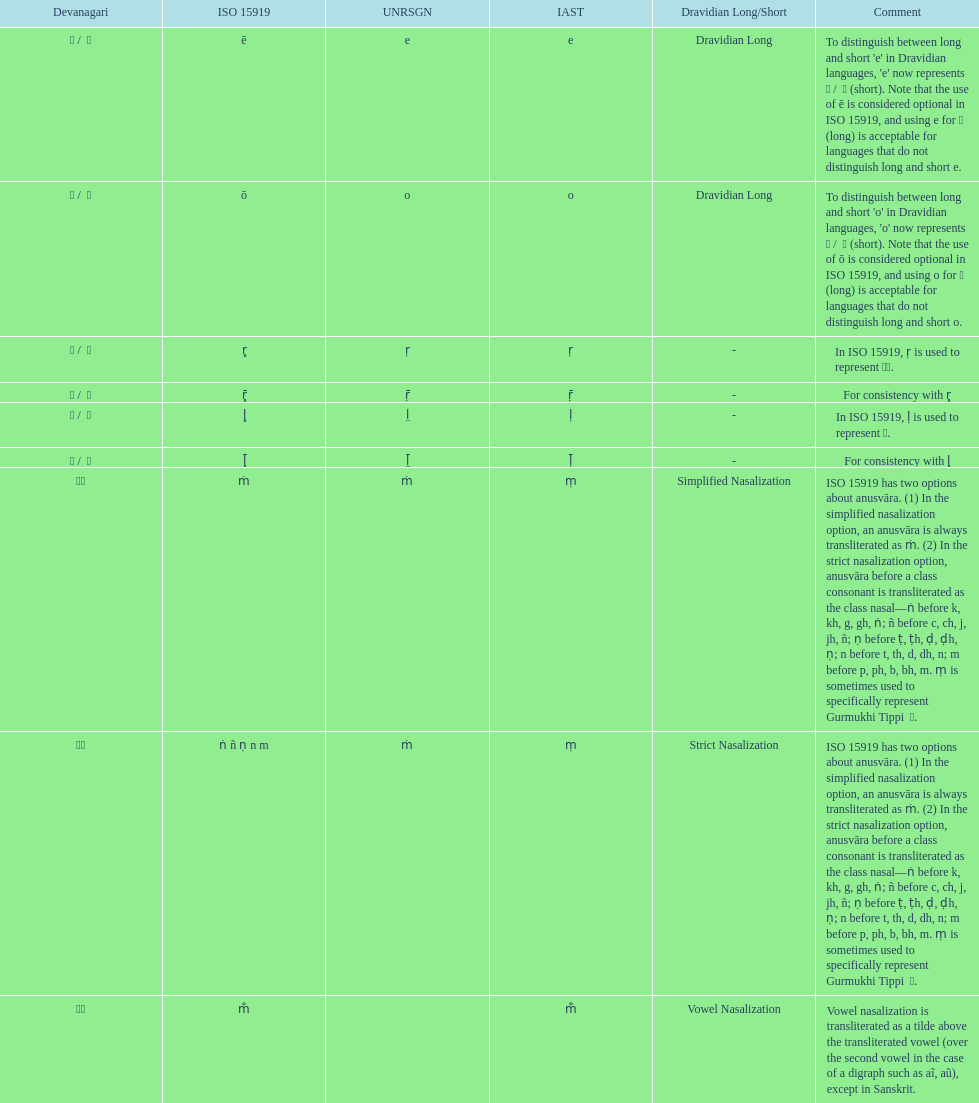What unrsgn is listed previous to the o? E. 